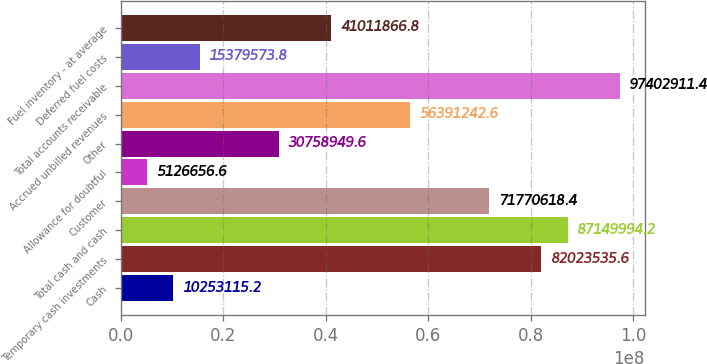<chart> <loc_0><loc_0><loc_500><loc_500><bar_chart><fcel>Cash<fcel>Temporary cash investments<fcel>Total cash and cash<fcel>Customer<fcel>Allowance for doubtful<fcel>Other<fcel>Accrued unbilled revenues<fcel>Total accounts receivable<fcel>Deferred fuel costs<fcel>Fuel inventory - at average<nl><fcel>1.02531e+07<fcel>8.20235e+07<fcel>8.715e+07<fcel>7.17706e+07<fcel>5.12666e+06<fcel>3.07589e+07<fcel>5.63912e+07<fcel>9.74029e+07<fcel>1.53796e+07<fcel>4.10119e+07<nl></chart> 